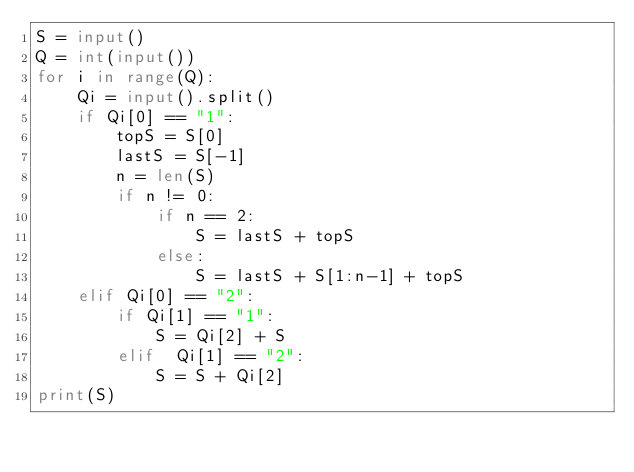Convert code to text. <code><loc_0><loc_0><loc_500><loc_500><_Python_>S = input()
Q = int(input())
for i in range(Q):
    Qi = input().split()
    if Qi[0] == "1":
        topS = S[0]
        lastS = S[-1]
        n = len(S)
        if n != 0:
            if n == 2:
                S = lastS + topS
            else:
                S = lastS + S[1:n-1] + topS
    elif Qi[0] == "2":
        if Qi[1] == "1":
            S = Qi[2] + S
        elif  Qi[1] == "2":
            S = S + Qi[2]
print(S)
</code> 